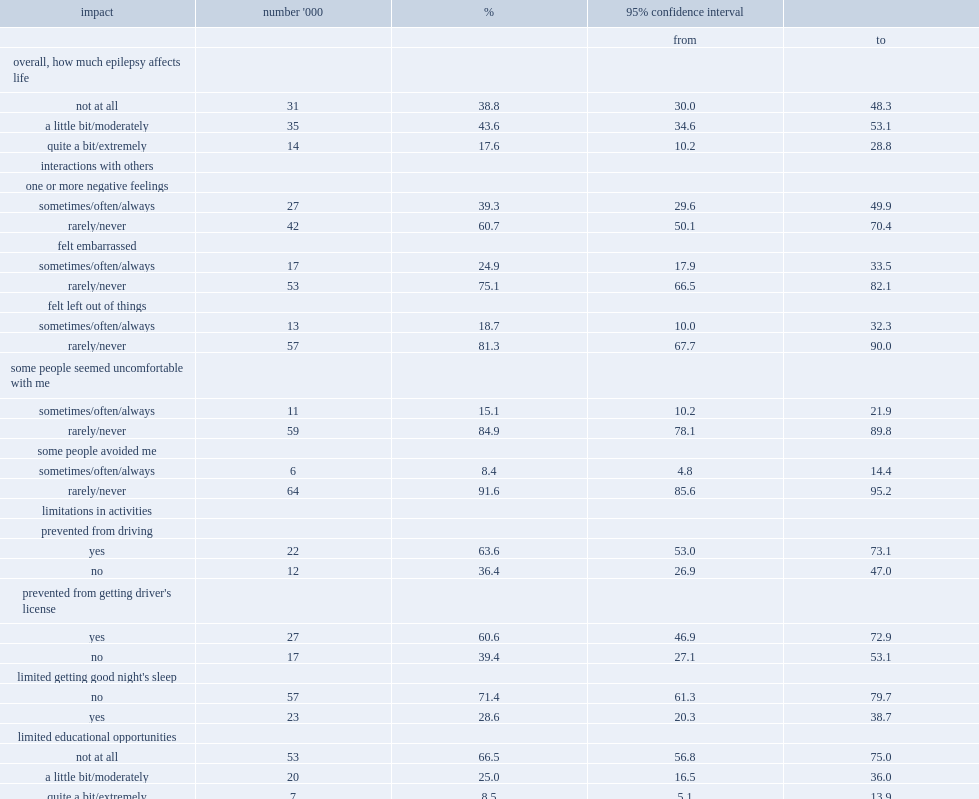Overall, how many people reported that epilepsy did not affect their life at all? 38.8. How many people said that their life was affected a little bit or moderately? 43.6. How many people felt that epilepsy affected their life quite a bit or extremely? 17.6. How many people reported negative feelings about their interactions with others because of their condition? 39.3. How many people were feeling embarrassed about their interactions with others? 24.9. How many people felt that they were left out of things in their interactions with others? 18.7. How many people felt that people were uncomfortable with them in their interactions with others? 15.1. How many people felt that people avoided them in their interactions with others? 8.4. How many people stated that they had been prevented from driving on occasion because of epilepsy? 63.6. How many people without a driver's license said that they are prevented from getting driver's license due to the epilepsy? 60.6. How many people's ability to get a good night's sleep was interfered with? 28.6. How many people reported that epilepsy did not limit their educational opportunities? 66.5. How many people reported some limitations were caused in their educational opportunities? 25. How many people reported that the limitations caused in their educational opportunities were more extreme? 8.5. How many people felt that epilepsy limited their employment opportunities a little bit or moderately? 21. How many people felt that epilepsy limited their employment opportunities quite a bit or extremely? 22.6. How many household residents with epilepsy were employed? 50.4. How many household residents with epilepsy did not have a job? 40.3. How many household residents with epilepsy were permanently unable to work? 9.3. Among those not working, how many people reported that this was because of epilepsy? 18.6. Among those not working, how many people reported that this was because of another illness, condition or disability? 19.3. Among those not working, how many people claimed that this was because of retirement. 25.6. Among those not working, how many household residents reported this was because of other circumstances. 36.5. Of those not working, how many said that they had had epilepsy when they worked in the past? 78.5. Of those not working, how many had made changes as a result of the condition? 27. 